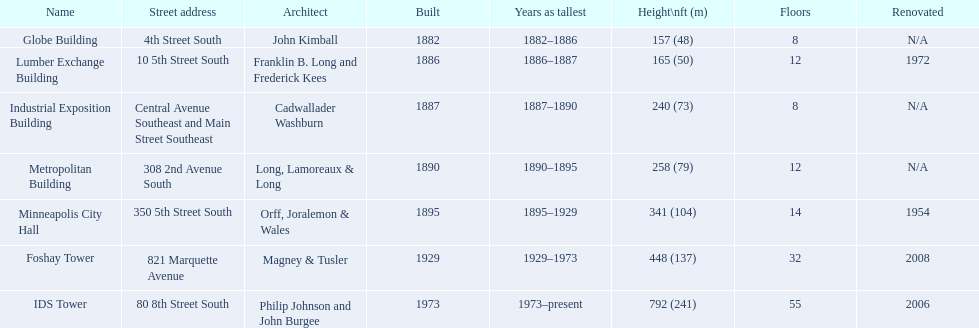Which building was initially recognized as the tallest? Globe Building. 